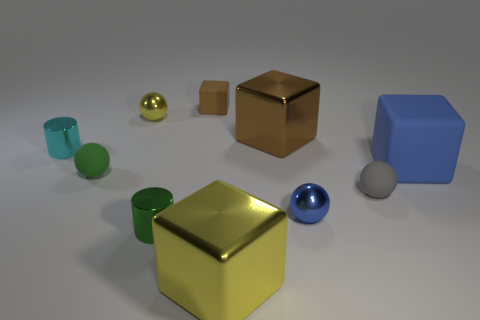Subtract all cubes. How many objects are left? 6 Add 2 blue shiny spheres. How many blue shiny spheres are left? 3 Add 6 small purple metal things. How many small purple metal things exist? 6 Subtract 0 red cylinders. How many objects are left? 10 Subtract all blue cubes. Subtract all large yellow objects. How many objects are left? 8 